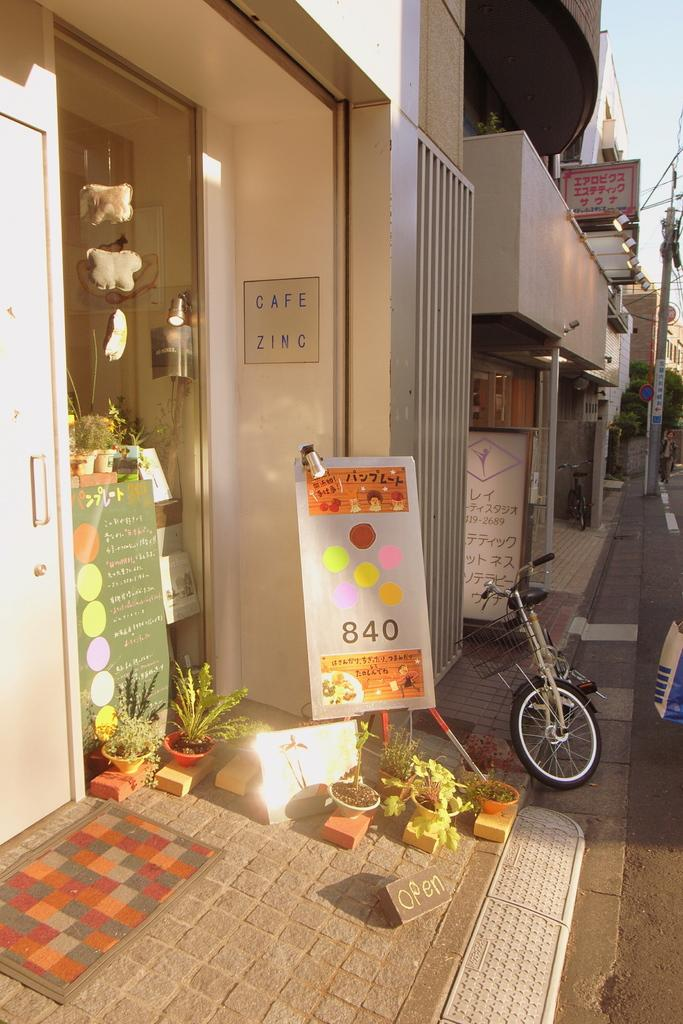What type of structures can be seen in the image? There are buildings in the image. What is the tall, thin object in the image? There is a pole in the image. What are the flat, rectangular objects in the image? There are boards in the image. What mode of transportation is present in the image? There is a bicycle in the image. What type of living organisms can be seen in the image? There are plants in the image. What feature allows access to the buildings in the image? There is a door in the image. What other objects can be seen in the image besides the ones mentioned? There are other objects in the image. What is placed on the path at the bottom of the image? There is a mat on the path at the bottom of the image. What shape is the pin used to hold the board in the image? There is no pin present in the image, and therefore no shape can be determined. What type of transportation is available at the airport in the image? There is no airport present in the image, so no transportation can be determined. 